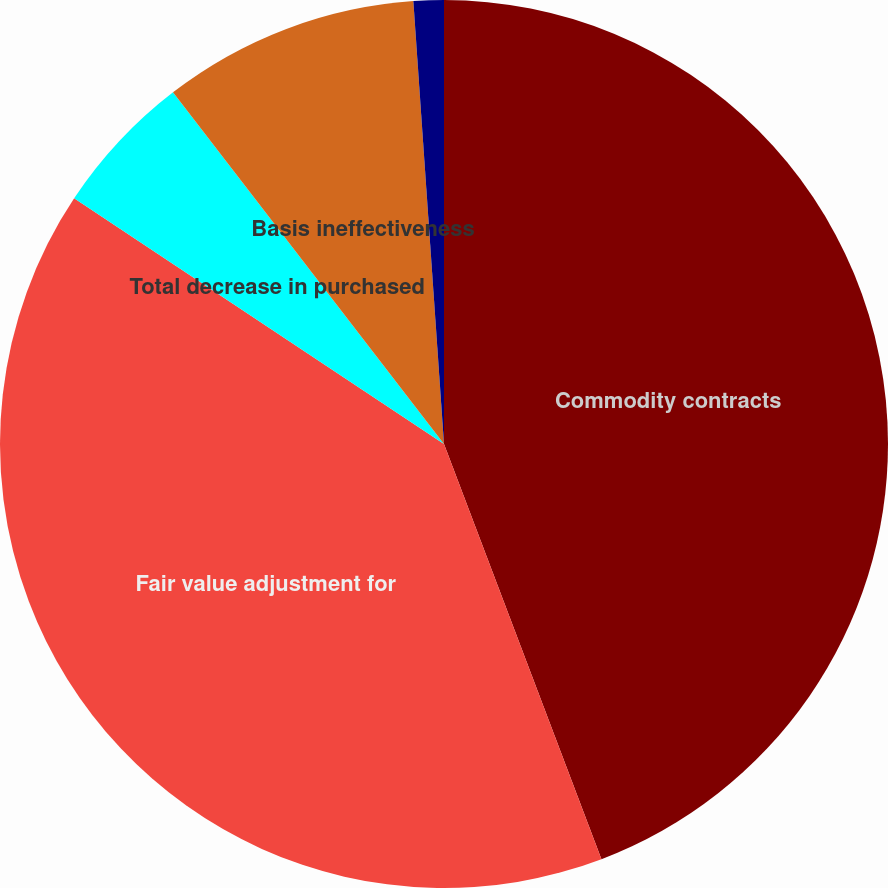Convert chart to OTSL. <chart><loc_0><loc_0><loc_500><loc_500><pie_chart><fcel>Commodity contracts<fcel>Fair value adjustment for<fcel>Total decrease in purchased<fcel>Basis ineffectiveness<fcel>Timing ineffectiveness<nl><fcel>44.23%<fcel>40.1%<fcel>5.22%<fcel>9.35%<fcel>1.1%<nl></chart> 